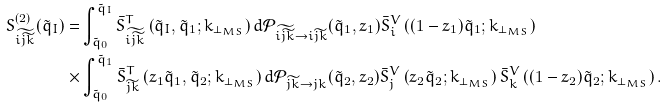Convert formula to latex. <formula><loc_0><loc_0><loc_500><loc_500>S _ { \widetilde { i \widetilde { j k } } } ^ { ( 2 ) } ( \tilde { q } _ { I } ) = & \int ^ { \tilde { q } _ { I } } _ { \tilde { q } _ { 0 } } \bar { S } _ { \widetilde { i \widetilde { j k } } } ^ { T } \left ( \tilde { q } _ { I } , \tilde { q } _ { 1 } ; k _ { \perp _ { M S } } \right ) d \mathcal { P } _ { \widetilde { i \widetilde { j k } } \to i \widetilde { j k } } ( \tilde { q } _ { 1 } , z _ { 1 } ) \bar { S } _ { i } ^ { V } \left ( ( 1 - z _ { 1 } ) \tilde { q } _ { 1 } ; k _ { \perp _ { M S } } \right ) \\ \times & \int ^ { \tilde { q } _ { 1 } } _ { \tilde { q } _ { 0 } } \bar { S } _ { \widetilde { j k } } ^ { T } \left ( z _ { 1 } \tilde { q } _ { 1 } , \tilde { q } _ { 2 } ; k _ { \perp _ { M S } } \right ) d \mathcal { P } _ { \widetilde { j k } \to j k } ( \tilde { q } _ { 2 } , z _ { 2 } ) \bar { S } _ { j } ^ { V } \left ( z _ { 2 } \tilde { q } _ { 2 } ; k _ { \perp _ { M S } } \right ) \bar { S } _ { k } ^ { V } \left ( ( 1 - z _ { 2 } ) \tilde { q } _ { 2 } ; k _ { \perp _ { M S } } \right ) .</formula> 